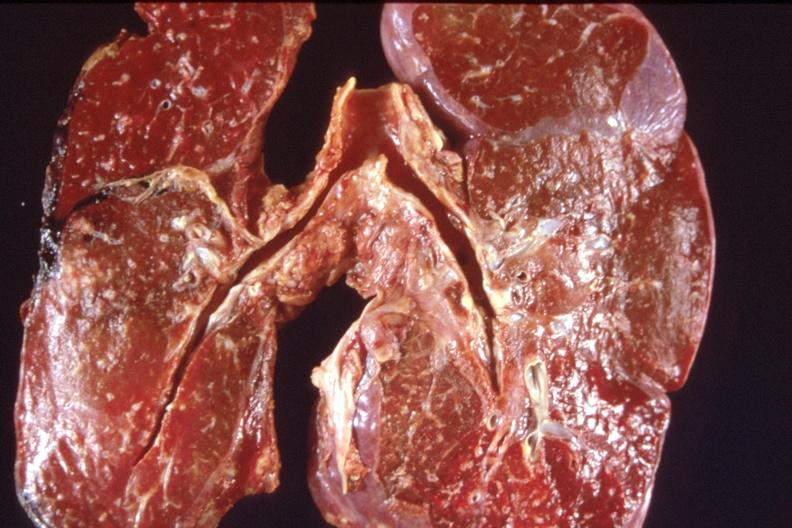does this image show lung, pulmonary edema and focal pneumonitis?
Answer the question using a single word or phrase. Yes 